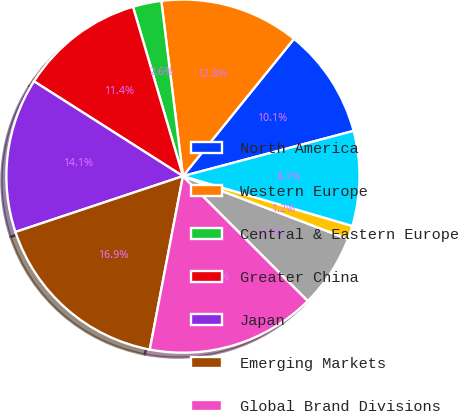Convert chart to OTSL. <chart><loc_0><loc_0><loc_500><loc_500><pie_chart><fcel>North America<fcel>Western Europe<fcel>Central & Eastern Europe<fcel>Greater China<fcel>Japan<fcel>Emerging Markets<fcel>Global Brand Divisions<fcel>Total NIKE Brand<fcel>Other Businesses<fcel>Corporate<nl><fcel>10.05%<fcel>12.78%<fcel>2.61%<fcel>11.41%<fcel>14.14%<fcel>16.87%<fcel>15.51%<fcel>6.7%<fcel>1.24%<fcel>8.68%<nl></chart> 